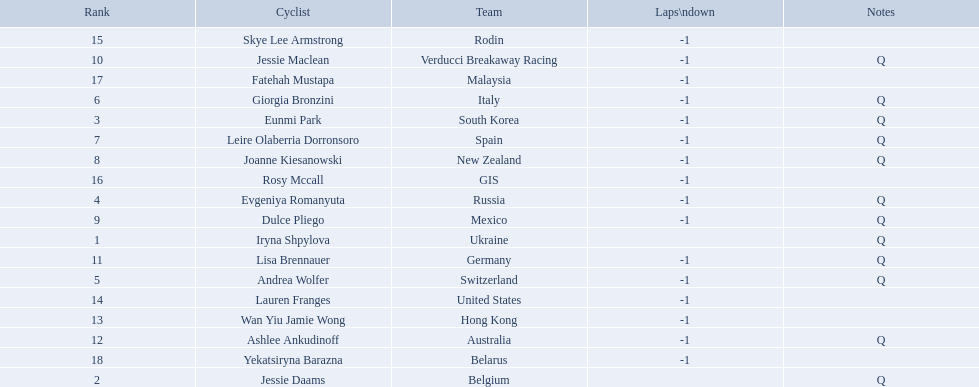Would you mind parsing the complete table? {'header': ['Rank', 'Cyclist', 'Team', 'Laps\\ndown', 'Notes'], 'rows': [['15', 'Skye Lee Armstrong', 'Rodin', '-1', ''], ['10', 'Jessie Maclean', 'Verducci Breakaway Racing', '-1', 'Q'], ['17', 'Fatehah Mustapa', 'Malaysia', '-1', ''], ['6', 'Giorgia Bronzini', 'Italy', '-1', 'Q'], ['3', 'Eunmi Park', 'South Korea', '-1', 'Q'], ['7', 'Leire Olaberria Dorronsoro', 'Spain', '-1', 'Q'], ['8', 'Joanne Kiesanowski', 'New Zealand', '-1', 'Q'], ['16', 'Rosy Mccall', 'GIS', '-1', ''], ['4', 'Evgeniya Romanyuta', 'Russia', '-1', 'Q'], ['9', 'Dulce Pliego', 'Mexico', '-1', 'Q'], ['1', 'Iryna Shpylova', 'Ukraine', '', 'Q'], ['11', 'Lisa Brennauer', 'Germany', '-1', 'Q'], ['5', 'Andrea Wolfer', 'Switzerland', '-1', 'Q'], ['14', 'Lauren Franges', 'United States', '-1', ''], ['13', 'Wan Yiu Jamie Wong', 'Hong Kong', '-1', ''], ['12', 'Ashlee Ankudinoff', 'Australia', '-1', 'Q'], ['18', 'Yekatsiryna Barazna', 'Belarus', '-1', ''], ['2', 'Jessie Daams', 'Belgium', '', 'Q']]} Who are all the cyclists? Iryna Shpylova, Jessie Daams, Eunmi Park, Evgeniya Romanyuta, Andrea Wolfer, Giorgia Bronzini, Leire Olaberria Dorronsoro, Joanne Kiesanowski, Dulce Pliego, Jessie Maclean, Lisa Brennauer, Ashlee Ankudinoff, Wan Yiu Jamie Wong, Lauren Franges, Skye Lee Armstrong, Rosy Mccall, Fatehah Mustapa, Yekatsiryna Barazna. What were their ranks? 1, 2, 3, 4, 5, 6, 7, 8, 9, 10, 11, 12, 13, 14, 15, 16, 17, 18. Who was ranked highest? Iryna Shpylova. 